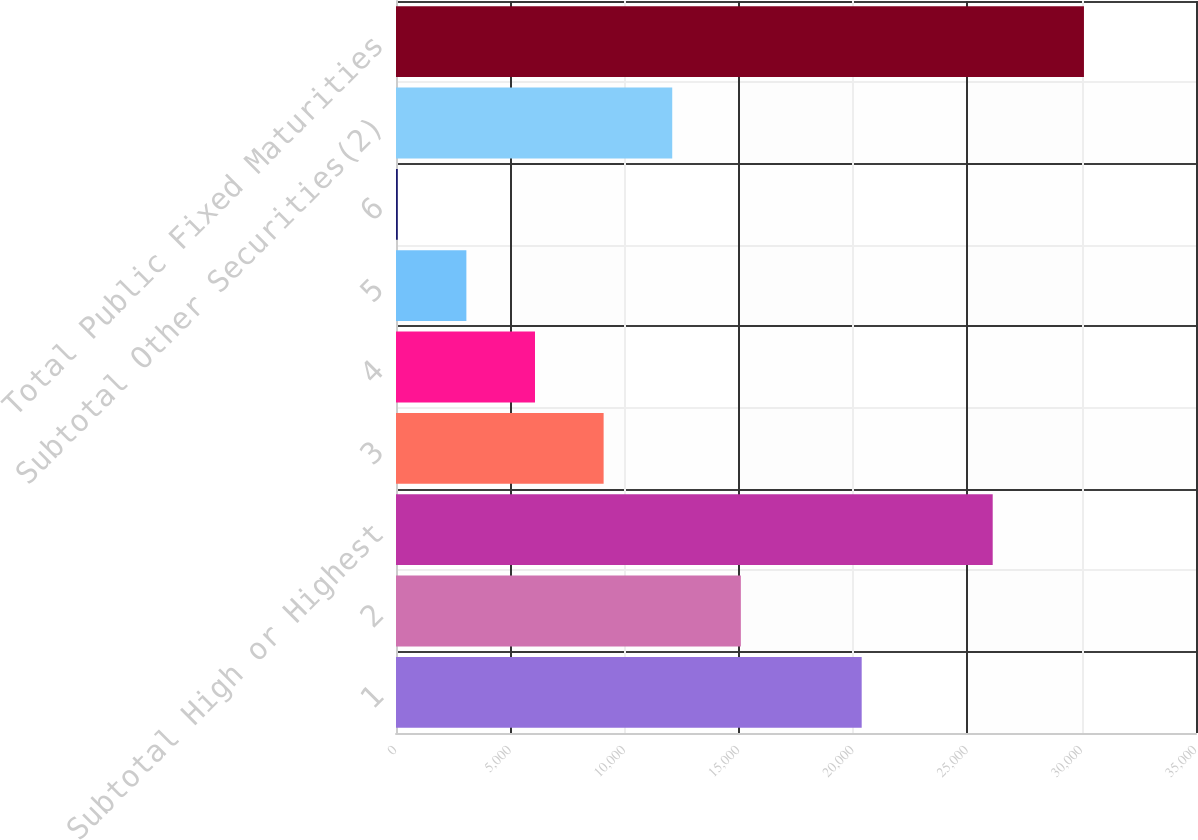Convert chart to OTSL. <chart><loc_0><loc_0><loc_500><loc_500><bar_chart><fcel>1<fcel>2<fcel>Subtotal High or Highest<fcel>3<fcel>4<fcel>5<fcel>6<fcel>Subtotal Other Securities(2)<fcel>Total Public Fixed Maturities<nl><fcel>20374<fcel>15087.5<fcel>26106<fcel>9083.3<fcel>6081.2<fcel>3079.1<fcel>77<fcel>12085.4<fcel>30098<nl></chart> 